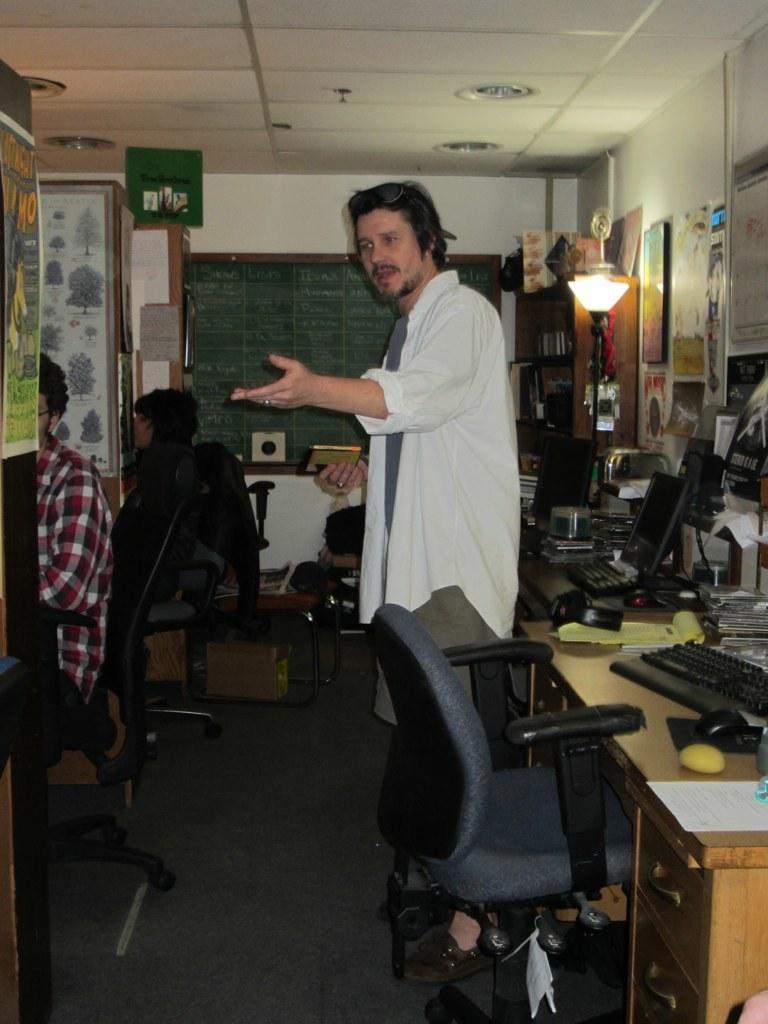Please provide a concise description of this image. This image is clicked inside the room. This image consist of three men. In the front, the man standing is wearing white shirt. In the front, there is a chair near the table. On which, there are keyboards, mouse, monitors and books. To the right, there is a wall on which many frames and posters are fixed. In the background, there is a board on the wall. 